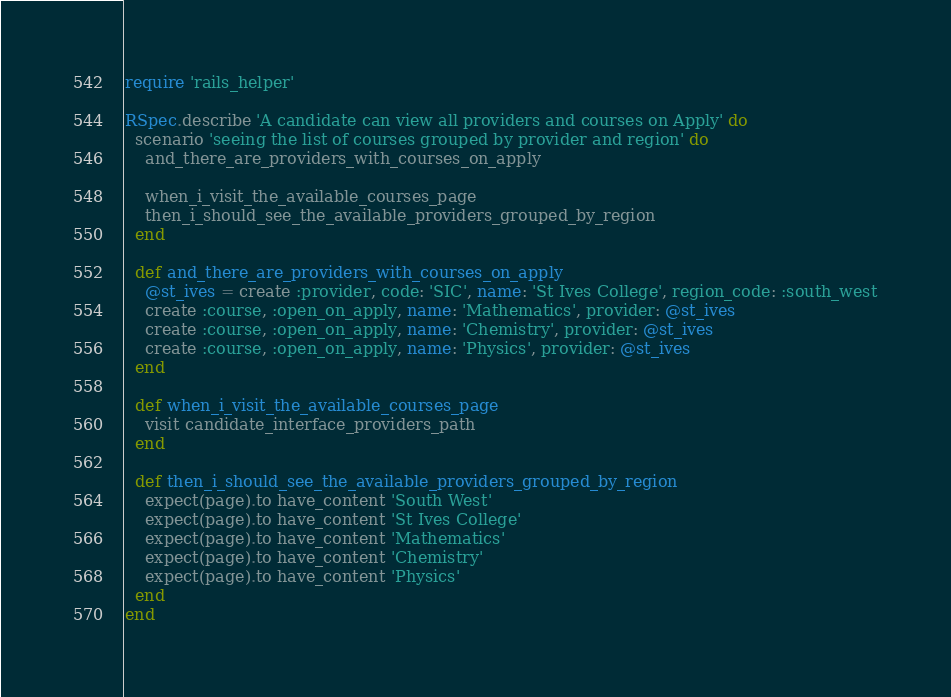Convert code to text. <code><loc_0><loc_0><loc_500><loc_500><_Ruby_>require 'rails_helper'

RSpec.describe 'A candidate can view all providers and courses on Apply' do
  scenario 'seeing the list of courses grouped by provider and region' do
    and_there_are_providers_with_courses_on_apply

    when_i_visit_the_available_courses_page
    then_i_should_see_the_available_providers_grouped_by_region
  end

  def and_there_are_providers_with_courses_on_apply
    @st_ives = create :provider, code: 'SIC', name: 'St Ives College', region_code: :south_west
    create :course, :open_on_apply, name: 'Mathematics', provider: @st_ives
    create :course, :open_on_apply, name: 'Chemistry', provider: @st_ives
    create :course, :open_on_apply, name: 'Physics', provider: @st_ives
  end

  def when_i_visit_the_available_courses_page
    visit candidate_interface_providers_path
  end

  def then_i_should_see_the_available_providers_grouped_by_region
    expect(page).to have_content 'South West'
    expect(page).to have_content 'St Ives College'
    expect(page).to have_content 'Mathematics'
    expect(page).to have_content 'Chemistry'
    expect(page).to have_content 'Physics'
  end
end
</code> 